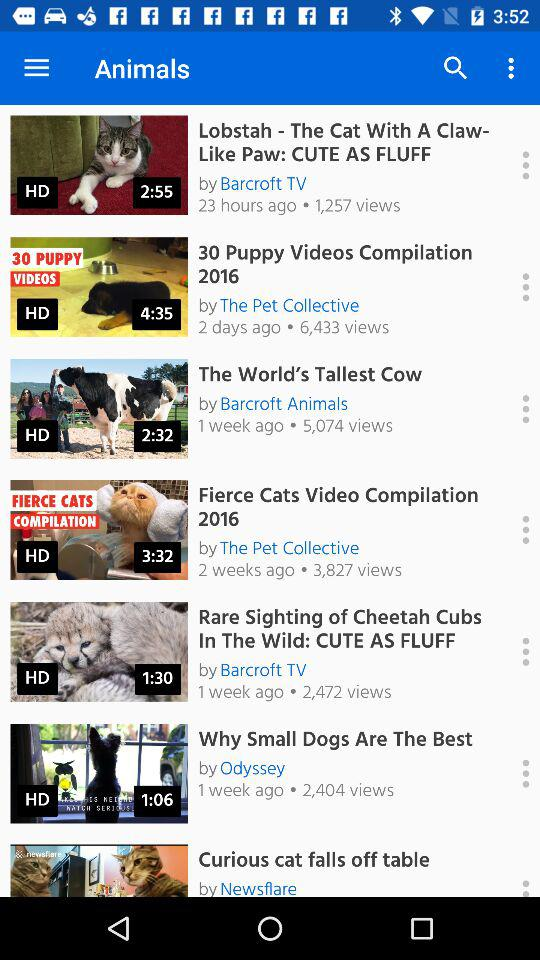When was the video "Lobstah - The Cat With A Claw- Like Paw: CUTE AS FLUFF" uploaded? The video "Lobstah - The Cat With A Claw- Like Paw: CUTE AS FLUFF" was uploaded 23 hours ago. 